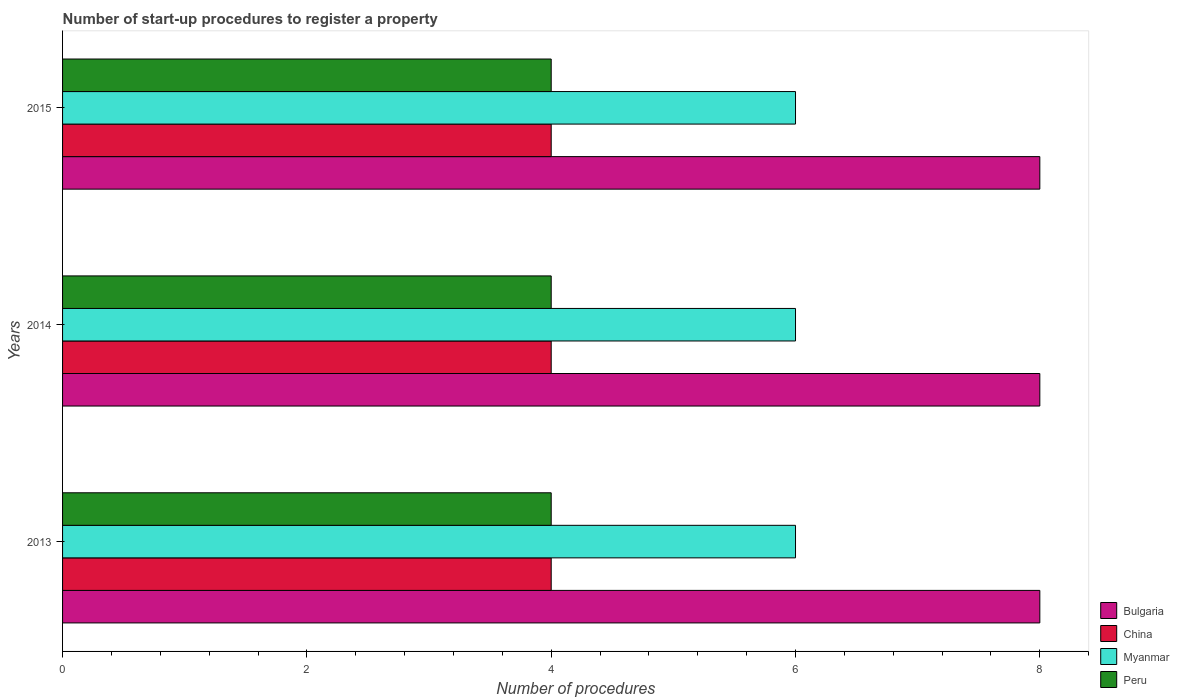How many different coloured bars are there?
Keep it short and to the point. 4. How many bars are there on the 3rd tick from the top?
Provide a short and direct response. 4. What is the label of the 3rd group of bars from the top?
Your response must be concise. 2013. In how many cases, is the number of bars for a given year not equal to the number of legend labels?
Your response must be concise. 0. What is the number of procedures required to register a property in Peru in 2014?
Your answer should be compact. 4. Across all years, what is the maximum number of procedures required to register a property in China?
Offer a very short reply. 4. Across all years, what is the minimum number of procedures required to register a property in Bulgaria?
Make the answer very short. 8. In which year was the number of procedures required to register a property in Peru maximum?
Ensure brevity in your answer.  2013. What is the difference between the number of procedures required to register a property in Myanmar in 2014 and that in 2015?
Ensure brevity in your answer.  0. What is the average number of procedures required to register a property in China per year?
Your answer should be very brief. 4. In the year 2013, what is the difference between the number of procedures required to register a property in Peru and number of procedures required to register a property in Myanmar?
Keep it short and to the point. -2. Is the number of procedures required to register a property in Myanmar in 2014 less than that in 2015?
Make the answer very short. No. What is the difference between the highest and the second highest number of procedures required to register a property in China?
Offer a very short reply. 0. What is the difference between the highest and the lowest number of procedures required to register a property in China?
Offer a very short reply. 0. Is the sum of the number of procedures required to register a property in Peru in 2014 and 2015 greater than the maximum number of procedures required to register a property in Bulgaria across all years?
Provide a short and direct response. No. What does the 3rd bar from the top in 2014 represents?
Make the answer very short. China. Is it the case that in every year, the sum of the number of procedures required to register a property in Bulgaria and number of procedures required to register a property in Peru is greater than the number of procedures required to register a property in Myanmar?
Offer a very short reply. Yes. How many bars are there?
Give a very brief answer. 12. Are the values on the major ticks of X-axis written in scientific E-notation?
Offer a terse response. No. What is the title of the graph?
Offer a very short reply. Number of start-up procedures to register a property. What is the label or title of the X-axis?
Ensure brevity in your answer.  Number of procedures. What is the Number of procedures in Peru in 2013?
Provide a short and direct response. 4. What is the Number of procedures of Bulgaria in 2014?
Your answer should be very brief. 8. What is the Number of procedures in Myanmar in 2014?
Ensure brevity in your answer.  6. What is the Number of procedures in China in 2015?
Your response must be concise. 4. What is the Number of procedures of Myanmar in 2015?
Offer a terse response. 6. What is the Number of procedures of Peru in 2015?
Give a very brief answer. 4. Across all years, what is the maximum Number of procedures of Bulgaria?
Offer a very short reply. 8. Across all years, what is the maximum Number of procedures of Myanmar?
Your response must be concise. 6. Across all years, what is the minimum Number of procedures of Bulgaria?
Your answer should be compact. 8. Across all years, what is the minimum Number of procedures in China?
Offer a very short reply. 4. Across all years, what is the minimum Number of procedures in Myanmar?
Provide a succinct answer. 6. What is the total Number of procedures in China in the graph?
Offer a terse response. 12. What is the total Number of procedures in Peru in the graph?
Keep it short and to the point. 12. What is the difference between the Number of procedures of Bulgaria in 2013 and that in 2014?
Ensure brevity in your answer.  0. What is the difference between the Number of procedures of China in 2013 and that in 2014?
Your answer should be compact. 0. What is the difference between the Number of procedures in Myanmar in 2013 and that in 2014?
Your answer should be very brief. 0. What is the difference between the Number of procedures in Peru in 2013 and that in 2015?
Provide a succinct answer. 0. What is the difference between the Number of procedures of Bulgaria in 2014 and that in 2015?
Give a very brief answer. 0. What is the difference between the Number of procedures in Peru in 2014 and that in 2015?
Make the answer very short. 0. What is the difference between the Number of procedures in Myanmar in 2013 and the Number of procedures in Peru in 2014?
Give a very brief answer. 2. What is the difference between the Number of procedures of Bulgaria in 2013 and the Number of procedures of China in 2015?
Your answer should be very brief. 4. What is the difference between the Number of procedures in China in 2013 and the Number of procedures in Myanmar in 2015?
Give a very brief answer. -2. What is the difference between the Number of procedures of China in 2013 and the Number of procedures of Peru in 2015?
Your answer should be very brief. 0. What is the difference between the Number of procedures in Myanmar in 2013 and the Number of procedures in Peru in 2015?
Make the answer very short. 2. What is the difference between the Number of procedures in Bulgaria in 2014 and the Number of procedures in China in 2015?
Your answer should be very brief. 4. What is the difference between the Number of procedures of Bulgaria in 2014 and the Number of procedures of Myanmar in 2015?
Offer a terse response. 2. What is the difference between the Number of procedures in Bulgaria in 2014 and the Number of procedures in Peru in 2015?
Offer a very short reply. 4. What is the difference between the Number of procedures in China in 2014 and the Number of procedures in Peru in 2015?
Make the answer very short. 0. What is the difference between the Number of procedures in Myanmar in 2014 and the Number of procedures in Peru in 2015?
Ensure brevity in your answer.  2. What is the average Number of procedures in Myanmar per year?
Provide a succinct answer. 6. In the year 2013, what is the difference between the Number of procedures of Bulgaria and Number of procedures of China?
Ensure brevity in your answer.  4. In the year 2013, what is the difference between the Number of procedures in Bulgaria and Number of procedures in Myanmar?
Offer a terse response. 2. In the year 2013, what is the difference between the Number of procedures of Myanmar and Number of procedures of Peru?
Your response must be concise. 2. In the year 2014, what is the difference between the Number of procedures in Bulgaria and Number of procedures in Myanmar?
Offer a terse response. 2. In the year 2014, what is the difference between the Number of procedures in Bulgaria and Number of procedures in Peru?
Provide a succinct answer. 4. In the year 2014, what is the difference between the Number of procedures in China and Number of procedures in Myanmar?
Offer a terse response. -2. What is the ratio of the Number of procedures of Myanmar in 2013 to that in 2014?
Your answer should be very brief. 1. What is the ratio of the Number of procedures of Peru in 2013 to that in 2014?
Your answer should be compact. 1. What is the ratio of the Number of procedures in Bulgaria in 2013 to that in 2015?
Your answer should be very brief. 1. What is the ratio of the Number of procedures of Bulgaria in 2014 to that in 2015?
Ensure brevity in your answer.  1. What is the ratio of the Number of procedures in Peru in 2014 to that in 2015?
Keep it short and to the point. 1. What is the difference between the highest and the second highest Number of procedures of Bulgaria?
Provide a short and direct response. 0. What is the difference between the highest and the second highest Number of procedures in Myanmar?
Provide a succinct answer. 0. What is the difference between the highest and the second highest Number of procedures of Peru?
Provide a succinct answer. 0. What is the difference between the highest and the lowest Number of procedures in China?
Keep it short and to the point. 0. What is the difference between the highest and the lowest Number of procedures of Myanmar?
Make the answer very short. 0. 